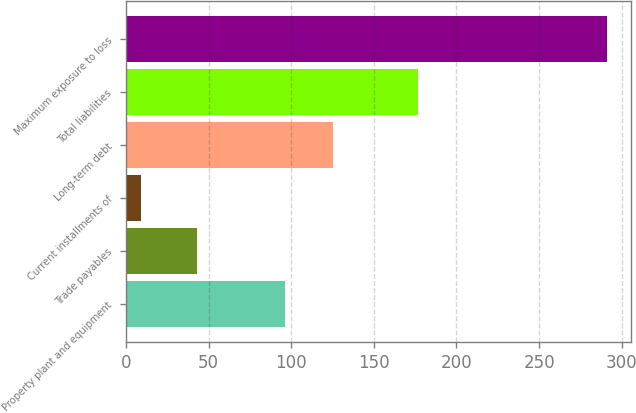Convert chart to OTSL. <chart><loc_0><loc_0><loc_500><loc_500><bar_chart><fcel>Property plant and equipment<fcel>Trade payables<fcel>Current installments of<fcel>Long-term debt<fcel>Total liabilities<fcel>Maximum exposure to loss<nl><fcel>96<fcel>43<fcel>9<fcel>125<fcel>177<fcel>291<nl></chart> 